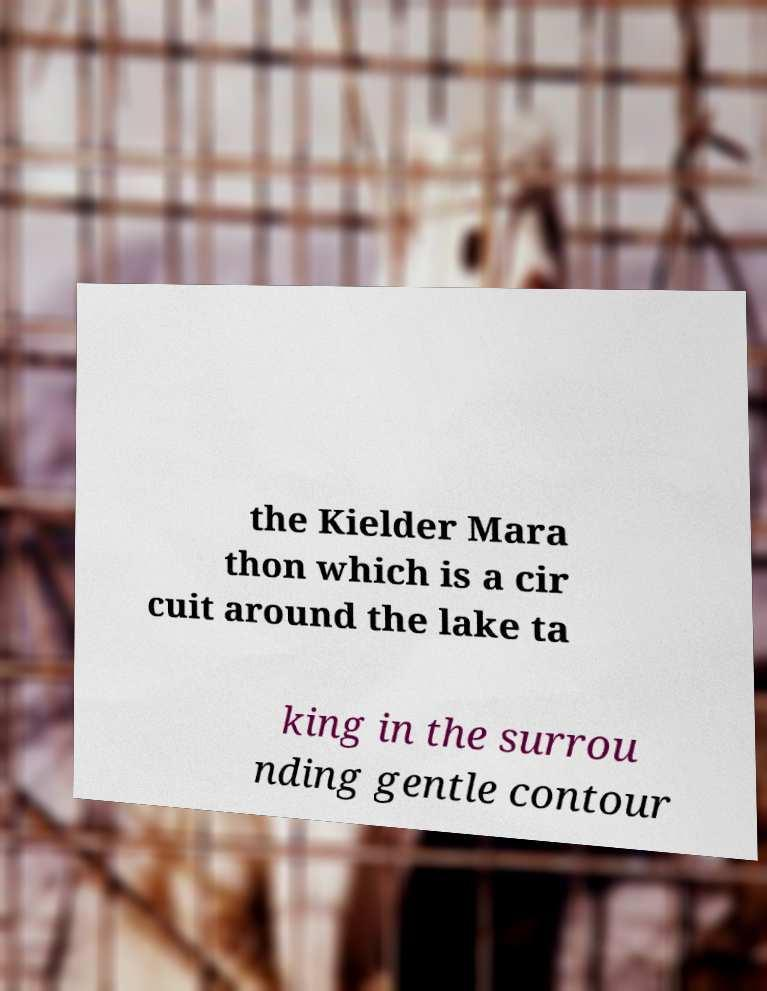Please identify and transcribe the text found in this image. the Kielder Mara thon which is a cir cuit around the lake ta king in the surrou nding gentle contour 